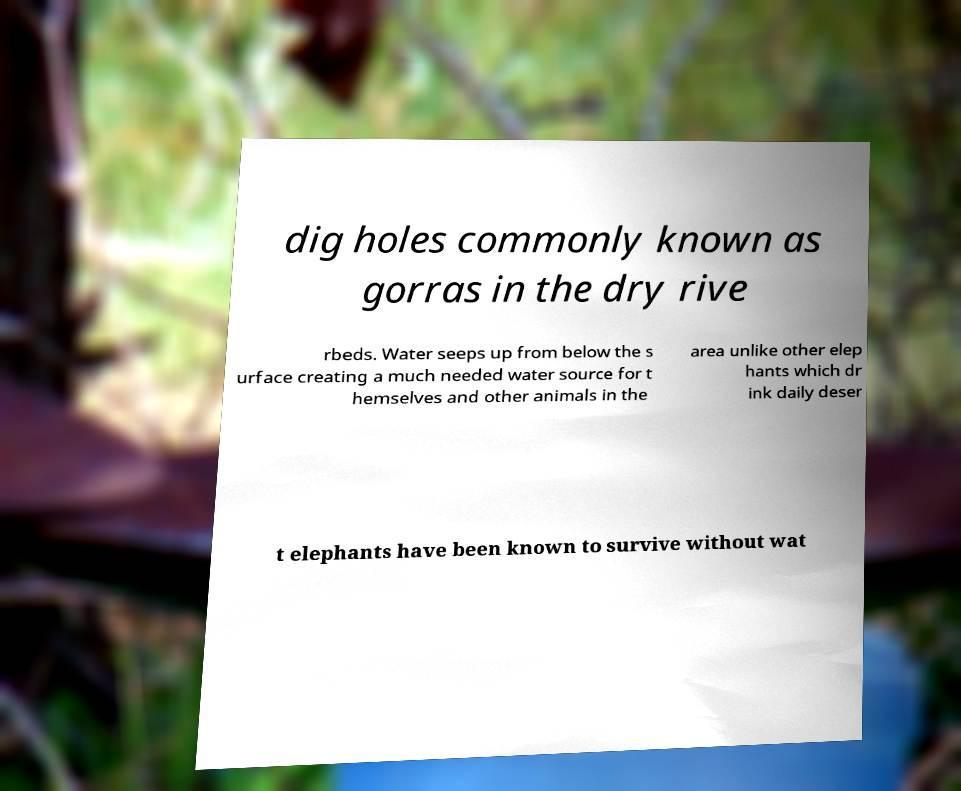I need the written content from this picture converted into text. Can you do that? dig holes commonly known as gorras in the dry rive rbeds. Water seeps up from below the s urface creating a much needed water source for t hemselves and other animals in the area unlike other elep hants which dr ink daily deser t elephants have been known to survive without wat 